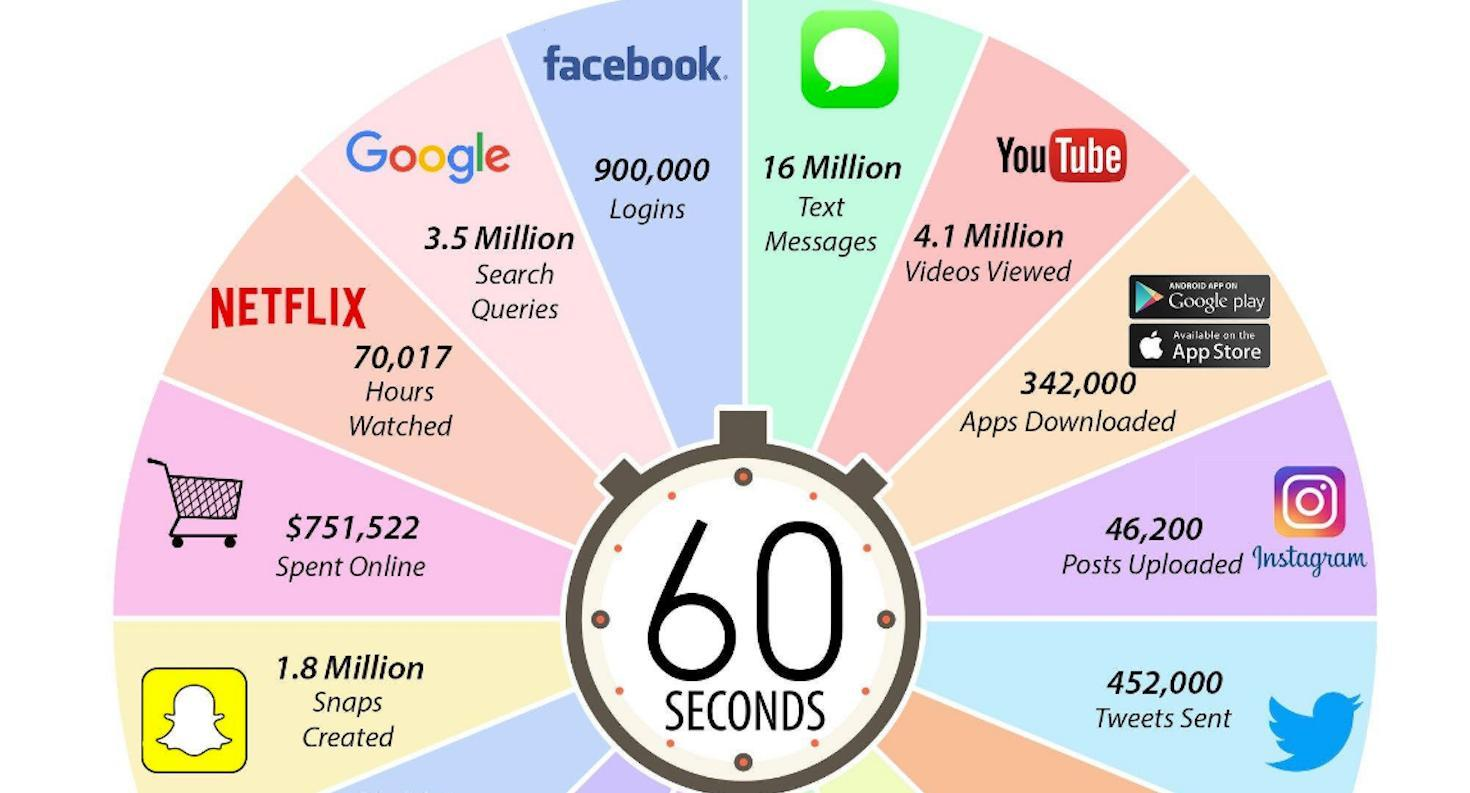How many queries are issued in Google in 60 secs 16 Million, 3.5 Million, or 4.1 Million?
Answer the question with a short phrase. 3.5 Million Which are the two sources used for downloading apps? Google play, App Store 